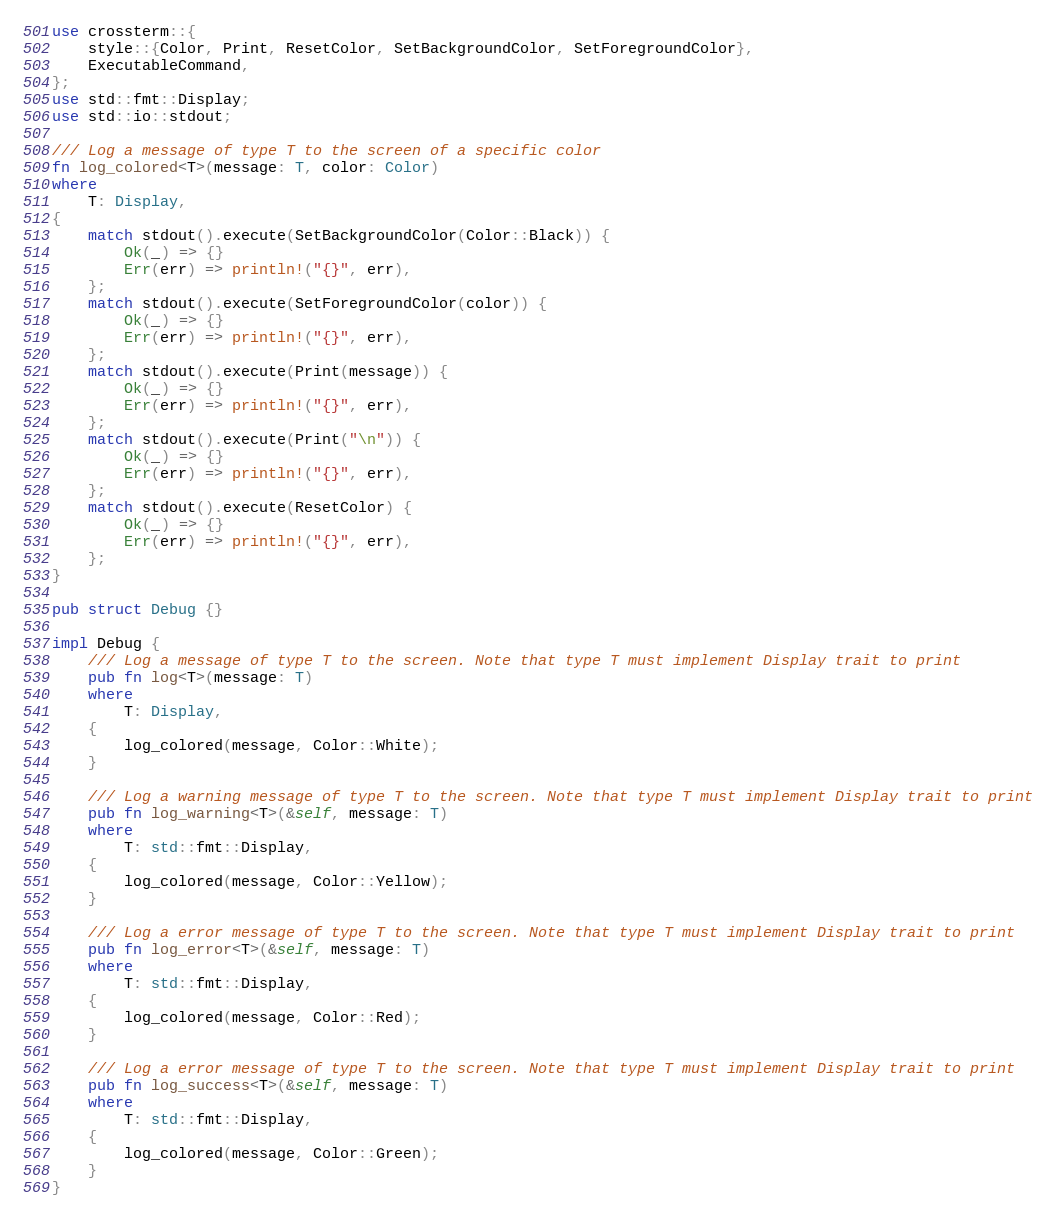Convert code to text. <code><loc_0><loc_0><loc_500><loc_500><_Rust_>use crossterm::{
    style::{Color, Print, ResetColor, SetBackgroundColor, SetForegroundColor},
    ExecutableCommand,
};
use std::fmt::Display;
use std::io::stdout;

/// Log a message of type T to the screen of a specific color
fn log_colored<T>(message: T, color: Color)
where
    T: Display,
{
    match stdout().execute(SetBackgroundColor(Color::Black)) {
        Ok(_) => {}
        Err(err) => println!("{}", err),
    };
    match stdout().execute(SetForegroundColor(color)) {
        Ok(_) => {}
        Err(err) => println!("{}", err),
    };
    match stdout().execute(Print(message)) {
        Ok(_) => {}
        Err(err) => println!("{}", err),
    };
    match stdout().execute(Print("\n")) {
        Ok(_) => {}
        Err(err) => println!("{}", err),
    };
    match stdout().execute(ResetColor) {
        Ok(_) => {}
        Err(err) => println!("{}", err),
    };
}

pub struct Debug {}

impl Debug {
    /// Log a message of type T to the screen. Note that type T must implement Display trait to print
    pub fn log<T>(message: T)
    where
        T: Display,
    {
        log_colored(message, Color::White);
    }

    /// Log a warning message of type T to the screen. Note that type T must implement Display trait to print
    pub fn log_warning<T>(&self, message: T)
    where
        T: std::fmt::Display,
    {
        log_colored(message, Color::Yellow);
    }

    /// Log a error message of type T to the screen. Note that type T must implement Display trait to print
    pub fn log_error<T>(&self, message: T)
    where
        T: std::fmt::Display,
    {
        log_colored(message, Color::Red);
    }

    /// Log a error message of type T to the screen. Note that type T must implement Display trait to print
    pub fn log_success<T>(&self, message: T)
    where
        T: std::fmt::Display,
    {
        log_colored(message, Color::Green);
    }
}
</code> 